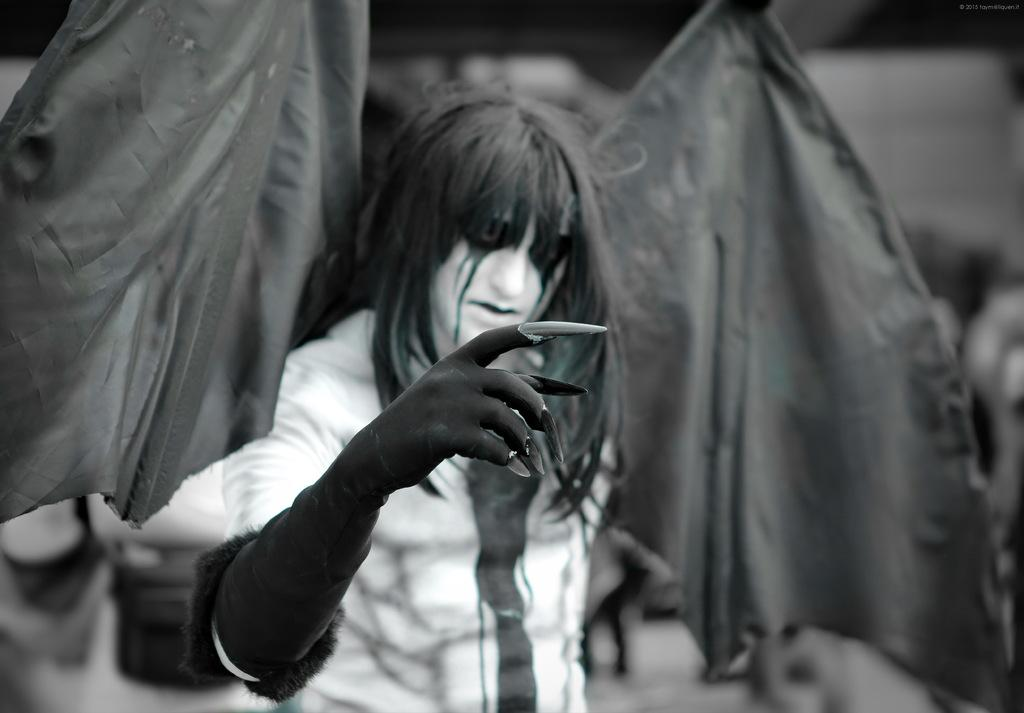What is the color scheme of the image? The image is black and white. Who is the main subject in the image? There is a girl in the middle of the image. What is a noticeable feature of the girl's hand? The girl has sharp and long nails on her hand. What can be seen behind the girl in the image? There are two flags behind the girl. What is an artistic detail on the girl's face? The girl has a painting on her face. What is the name of the deer in the image? There is no deer present in the image; it features a girl with flags and a painted face. How does the girl slip on the ice in the image? There is no ice or slipping depicted in the image; the girl is standing still with flags and a painted face. 